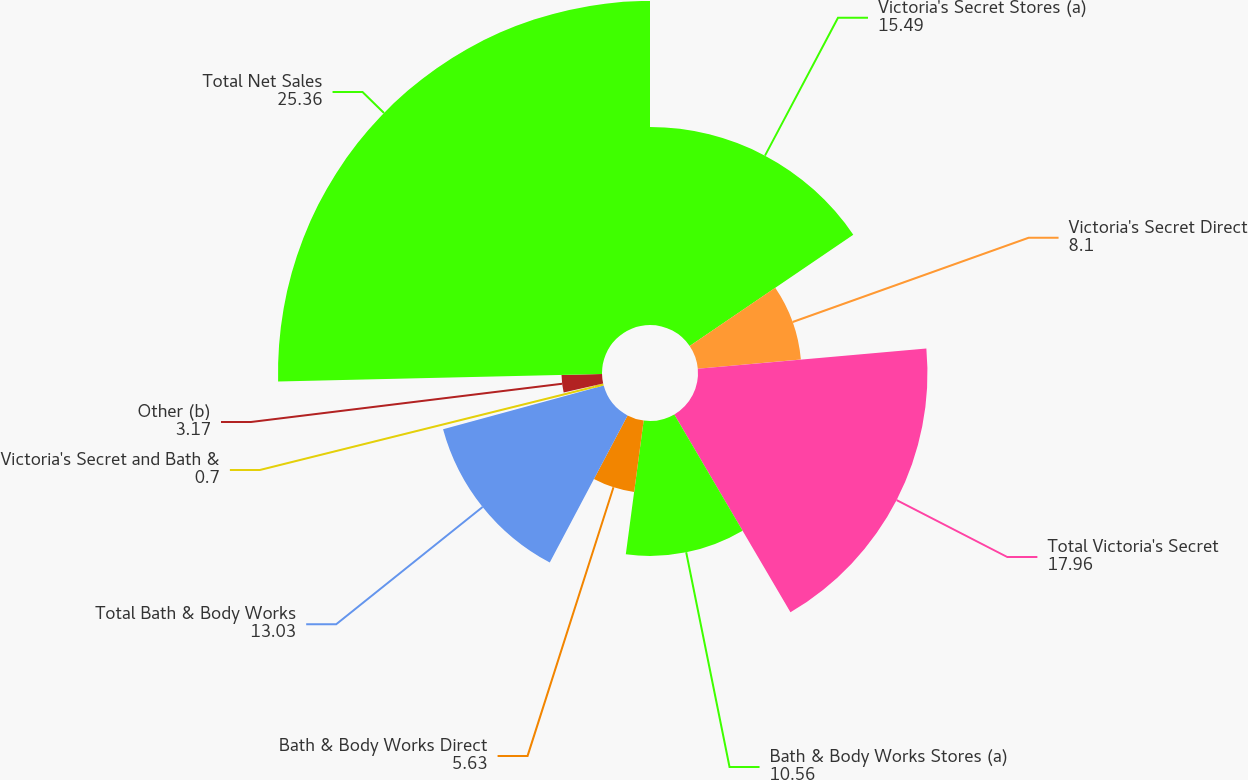Convert chart to OTSL. <chart><loc_0><loc_0><loc_500><loc_500><pie_chart><fcel>Victoria's Secret Stores (a)<fcel>Victoria's Secret Direct<fcel>Total Victoria's Secret<fcel>Bath & Body Works Stores (a)<fcel>Bath & Body Works Direct<fcel>Total Bath & Body Works<fcel>Victoria's Secret and Bath &<fcel>Other (b)<fcel>Total Net Sales<nl><fcel>15.49%<fcel>8.1%<fcel>17.96%<fcel>10.56%<fcel>5.63%<fcel>13.03%<fcel>0.7%<fcel>3.17%<fcel>25.36%<nl></chart> 